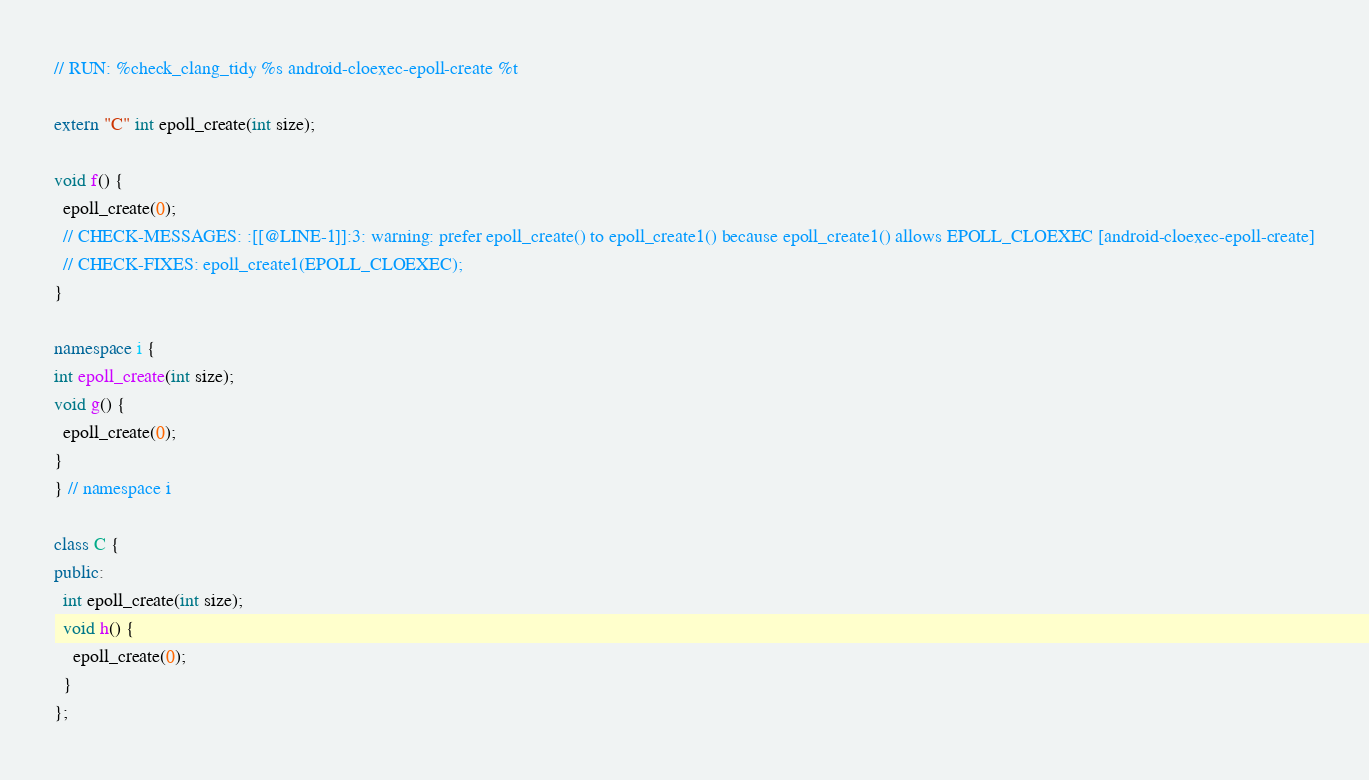Convert code to text. <code><loc_0><loc_0><loc_500><loc_500><_C++_>// RUN: %check_clang_tidy %s android-cloexec-epoll-create %t

extern "C" int epoll_create(int size);

void f() {
  epoll_create(0);
  // CHECK-MESSAGES: :[[@LINE-1]]:3: warning: prefer epoll_create() to epoll_create1() because epoll_create1() allows EPOLL_CLOEXEC [android-cloexec-epoll-create]
  // CHECK-FIXES: epoll_create1(EPOLL_CLOEXEC);
}

namespace i {
int epoll_create(int size);
void g() {
  epoll_create(0);
}
} // namespace i

class C {
public:
  int epoll_create(int size);
  void h() {
    epoll_create(0);
  }
};
</code> 